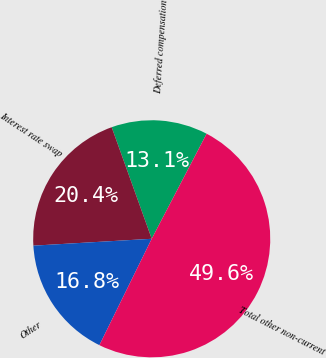Convert chart to OTSL. <chart><loc_0><loc_0><loc_500><loc_500><pie_chart><fcel>Deferred compensation<fcel>Interest rate swap<fcel>Other<fcel>Total other non-current<nl><fcel>13.15%<fcel>20.44%<fcel>16.8%<fcel>49.61%<nl></chart> 